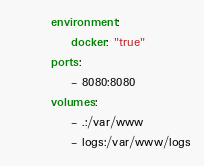Convert code to text. <code><loc_0><loc_0><loc_500><loc_500><_YAML_>        environment:
            docker: "true"
        ports:
            - 8080:8080
        volumes:
            - .:/var/www
            - logs:/var/www/logs
</code> 